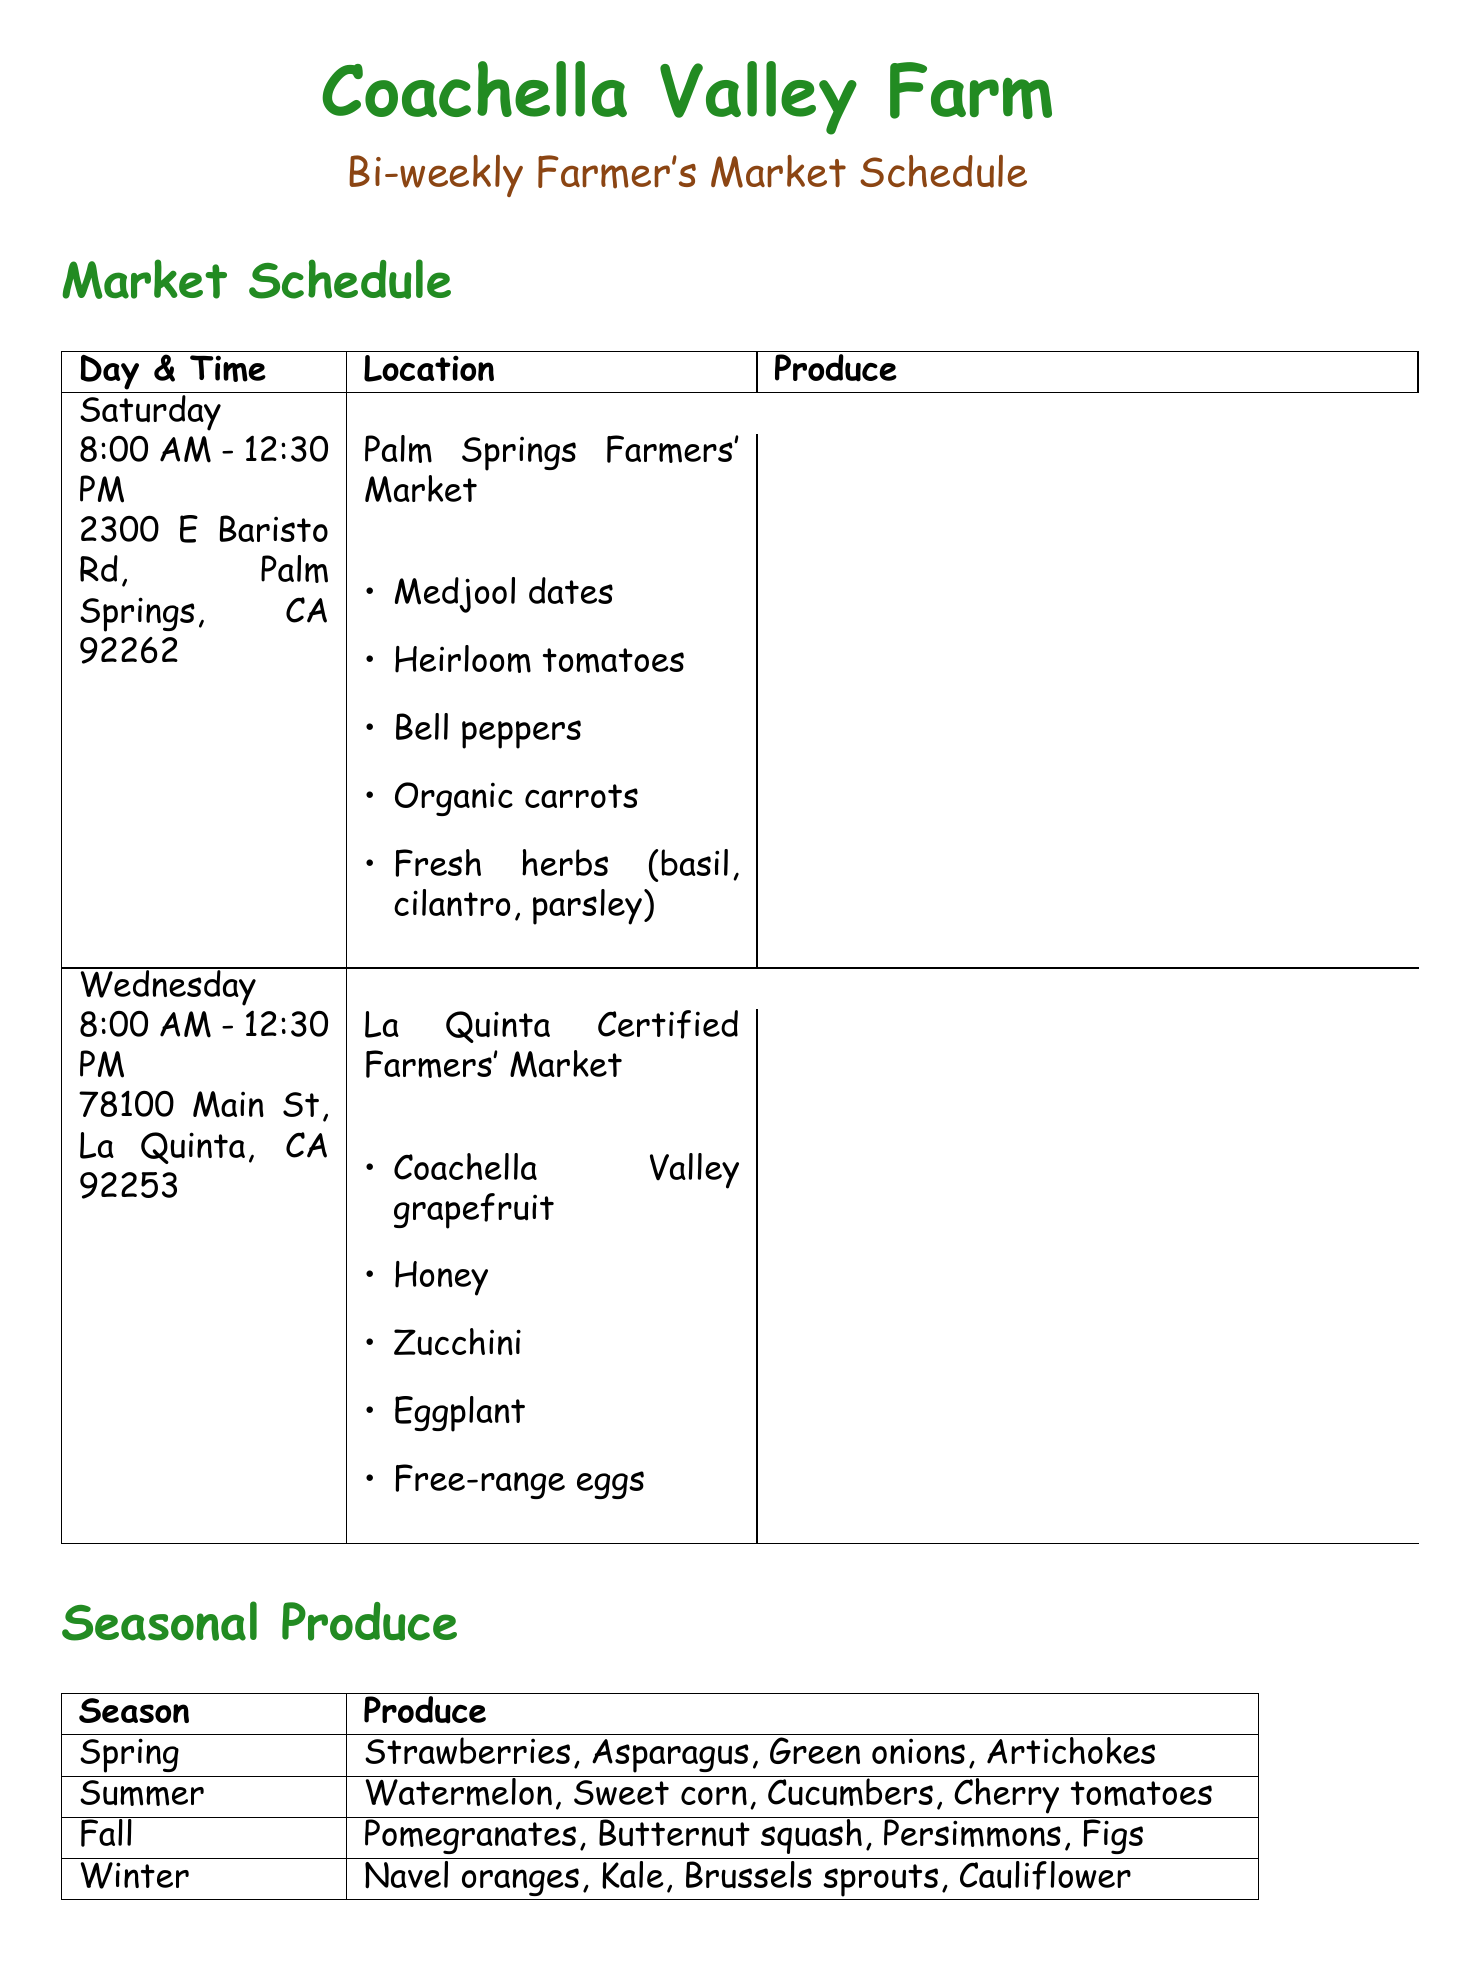What is the frequency of the Palm Springs Farmers' Market? The document specifies that the Palm Springs Farmers' Market occurs every other week on Saturdays.
Answer: Every other week Where is the La Quinta Certified Farmers' Market located? The address of the La Quinta Certified Farmers' Market is provided in the schedule.
Answer: 78100 Main St, La Quinta, CA 92253 What are the operating hours for the Wednesday market? The times for the market on Wednesday are detailed in the document.
Answer: 8:00 AM - 12:30 PM Which produce is available at the Palm Springs Farmers' Market? The document lists specific produce to bring to the Palm Springs market.
Answer: Medjool dates, Heirloom tomatoes, Bell peppers, Organic carrots, Fresh herbs Which seasonal produce is available in summer? The document includes a section dedicated to seasonal produce, specifying what's available in summer.
Answer: Watermelon, Sweet corn, Cucumbers, Cherry tomatoes What special item is available year-round? The document lists several special items and indicates which are available all year.
Answer: Coachella Valley Honey How many items are in the preparation checklist? The section provides a list of tasks for market preparation, which can be counted.
Answer: Six What day is the Old Town La Quinta Farmers' Market held? The document specifically states the day for the Old Town La Quinta Farmers' Market.
Answer: Sunday 